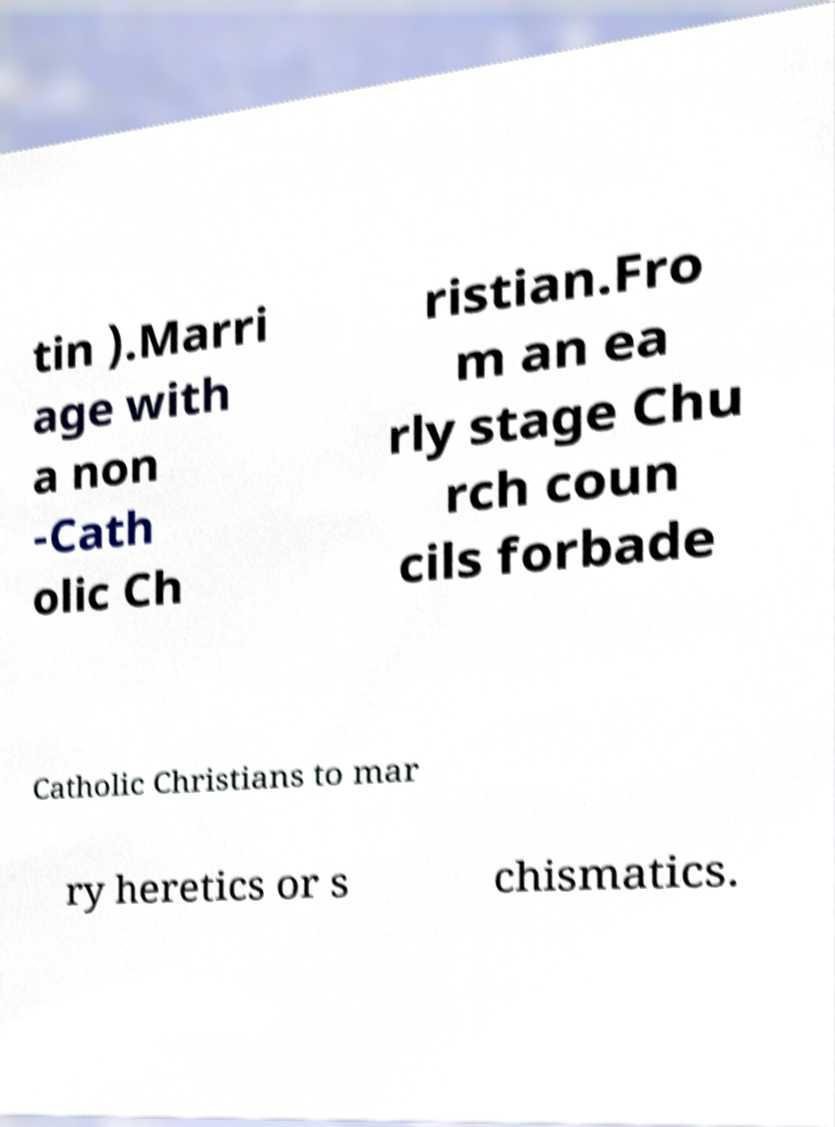I need the written content from this picture converted into text. Can you do that? tin ).Marri age with a non -Cath olic Ch ristian.Fro m an ea rly stage Chu rch coun cils forbade Catholic Christians to mar ry heretics or s chismatics. 